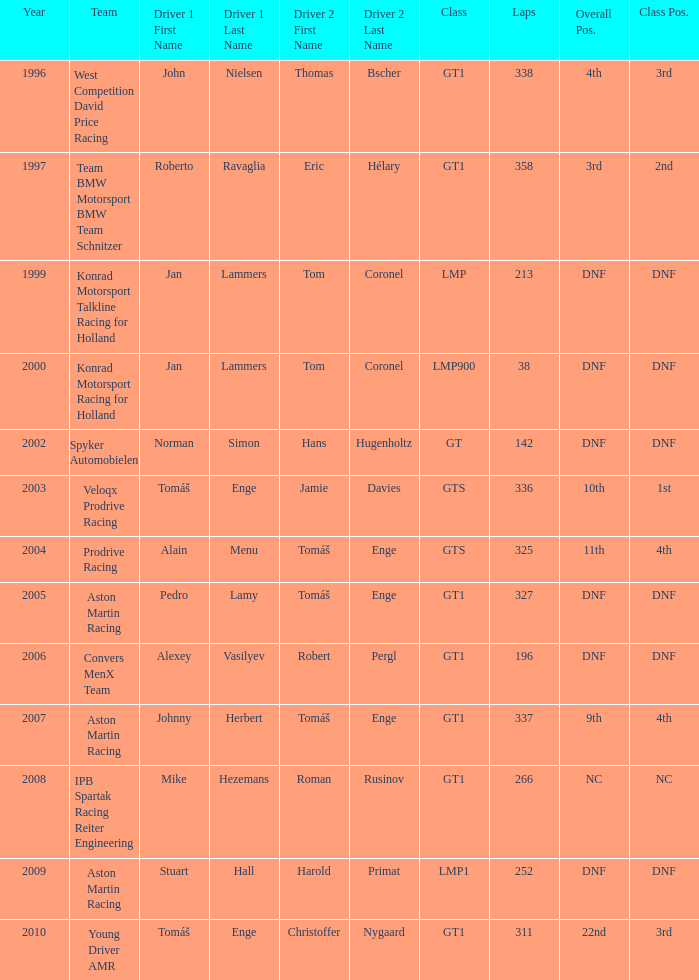Which position finished 3rd in class and completed less than 338 laps? 22nd. Could you parse the entire table? {'header': ['Year', 'Team', 'Driver 1 First Name', 'Driver 1 Last Name', 'Driver 2 First Name', 'Driver 2 Last Name', 'Class', 'Laps', 'Overall Pos.', 'Class Pos.'], 'rows': [['1996', 'West Competition David Price Racing', 'John', 'Nielsen', 'Thomas', 'Bscher', 'GT1', '338', '4th', '3rd'], ['1997', 'Team BMW Motorsport BMW Team Schnitzer', 'Roberto', 'Ravaglia', 'Eric', 'Hélary', 'GT1', '358', '3rd', '2nd'], ['1999', 'Konrad Motorsport Talkline Racing for Holland', 'Jan', 'Lammers', 'Tom', 'Coronel', 'LMP', '213', 'DNF', 'DNF'], ['2000', 'Konrad Motorsport Racing for Holland', 'Jan', 'Lammers', 'Tom', 'Coronel', 'LMP900', '38', 'DNF', 'DNF'], ['2002', 'Spyker Automobielen', 'Norman', 'Simon', 'Hans', 'Hugenholtz', 'GT', '142', 'DNF', 'DNF'], ['2003', 'Veloqx Prodrive Racing', 'Tomáš', 'Enge', 'Jamie', 'Davies', 'GTS', '336', '10th', '1st'], ['2004', 'Prodrive Racing', 'Alain', 'Menu', 'Tomáš', 'Enge', 'GTS', '325', '11th', '4th'], ['2005', 'Aston Martin Racing', 'Pedro', 'Lamy', 'Tomáš', 'Enge', 'GT1', '327', 'DNF', 'DNF'], ['2006', 'Convers MenX Team', 'Alexey', 'Vasilyev', 'Robert', 'Pergl', 'GT1', '196', 'DNF', 'DNF'], ['2007', 'Aston Martin Racing', 'Johnny', 'Herbert', 'Tomáš', 'Enge', 'GT1', '337', '9th', '4th'], ['2008', 'IPB Spartak Racing Reiter Engineering', 'Mike', 'Hezemans', 'Roman', 'Rusinov', 'GT1', '266', 'NC', 'NC'], ['2009', 'Aston Martin Racing', 'Stuart', 'Hall', 'Harold', 'Primat', 'LMP1', '252', 'DNF', 'DNF'], ['2010', 'Young Driver AMR', 'Tomáš', 'Enge', 'Christoffer', 'Nygaard', 'GT1', '311', '22nd', '3rd']]} 